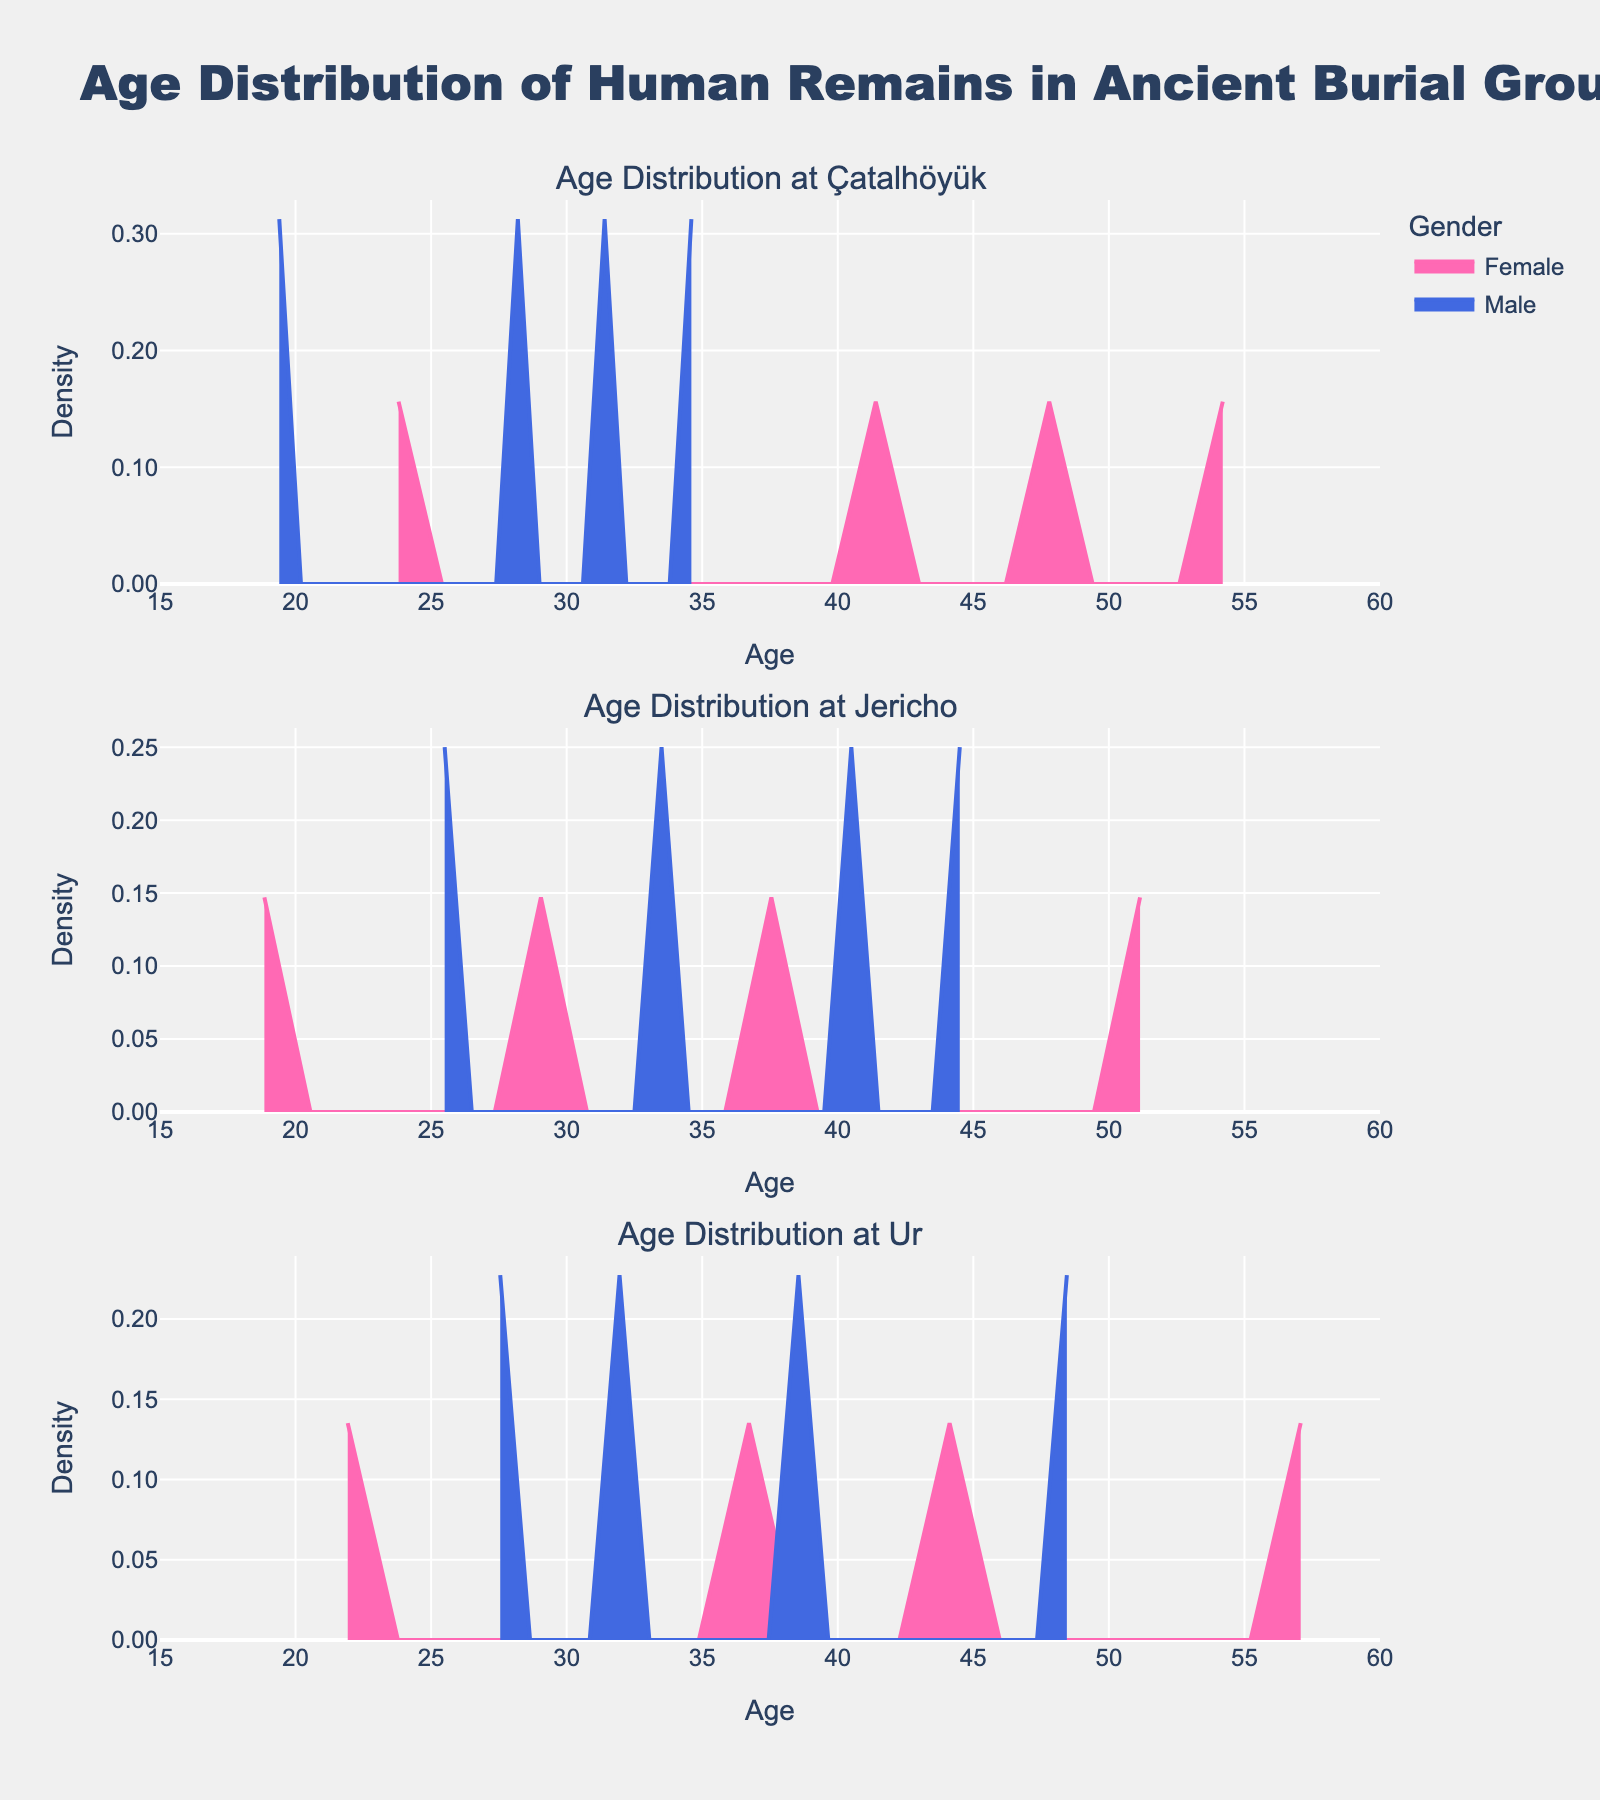What's the title of the figure? The title is located at the top of the figure. It reads, "Age Distribution of Human Remains in Ancient Burial Grounds." This can be directly seen from the visual.
Answer: Age Distribution of Human Remains in Ancient Burial Grounds What are the x-axis and y-axis labels in the figure? The x-axis label at the bottom of each subplot is "Age," ranging from 15 to 60. The y-axis label on the left side of each subplot is "Density," formatted with two decimal places.
Answer: Age (x-axis) and Density (y-axis) Which gender has a higher peak density at the Jericho site? By comparing the filled areas under the curves for Male and Female at the Jericho subplot, the peak density for Males is visibly higher than for Females.
Answer: Male What is the color scheme used for representing different genders? The colors used are Pink for Females and Blue for Males. This can be inferred from the colors of the filled areas under the density curves and the legend.
Answer: Pink for Female and Blue for Male At which site is the median age for females the highest? By visually inspecting the density plots for Females across all sites, the highest peak and a more right-shifted distribution are observed at Ur, indicating a higher median age.
Answer: Ur Is there a site where the age distribution for males appears more spread out than for females? At Çatalhöyük, the male age distribution has a wider spread compared to females, indicating greater variability in male ages.
Answer: Çatalhöyük Compare the age distributions of males between the three sites. Males in Çatalhöyük show a wider spread compared to more centralized distributions in Jericho and Ur. Ur also shows a slight widening indicating more variability compared to Jericho.
Answer: Çatalhöyük has the widest spread, followed by Ur, and Jericho How do the densities differ for males and females at Çatalhöyük in the age range 30 to 40? The density plot shows that within the age range of 30 to 40, females at Çatalhöyük have multiple smaller peaks while males have a single noticeable peak around age 35.
Answer: Females have multiple peaks, males have a single peak at 35 What site shows a higher density for females compared to males? The subplot for Ur indicates that females have a slightly higher peak density compared to males.
Answer: Ur 